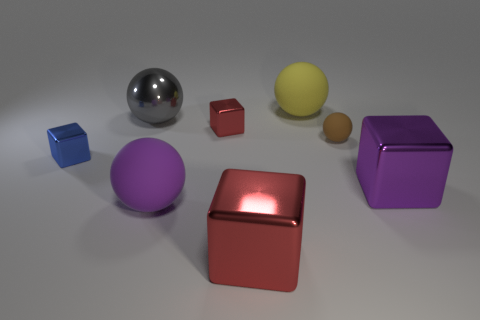What number of brown rubber spheres are behind the red shiny block behind the large red shiny cube?
Keep it short and to the point. 0. Does the brown thing have the same material as the gray object?
Your response must be concise. No. Is there a block made of the same material as the tiny brown thing?
Offer a very short reply. No. What is the color of the metallic block that is behind the tiny brown matte sphere that is right of the big shiny block in front of the purple shiny object?
Offer a very short reply. Red. What number of purple objects are either big metal cylinders or big metallic blocks?
Provide a short and direct response. 1. What number of other red metallic things have the same shape as the tiny red metal thing?
Your response must be concise. 1. What is the shape of the red thing that is the same size as the yellow ball?
Provide a succinct answer. Cube. Are there any small blue cubes in front of the big yellow rubber thing?
Give a very brief answer. Yes. Are there any purple blocks left of the big metallic thing that is behind the purple metallic cube?
Offer a terse response. No. Is the number of small red metallic objects left of the blue shiny cube less than the number of matte things that are in front of the yellow rubber object?
Your answer should be very brief. Yes. 